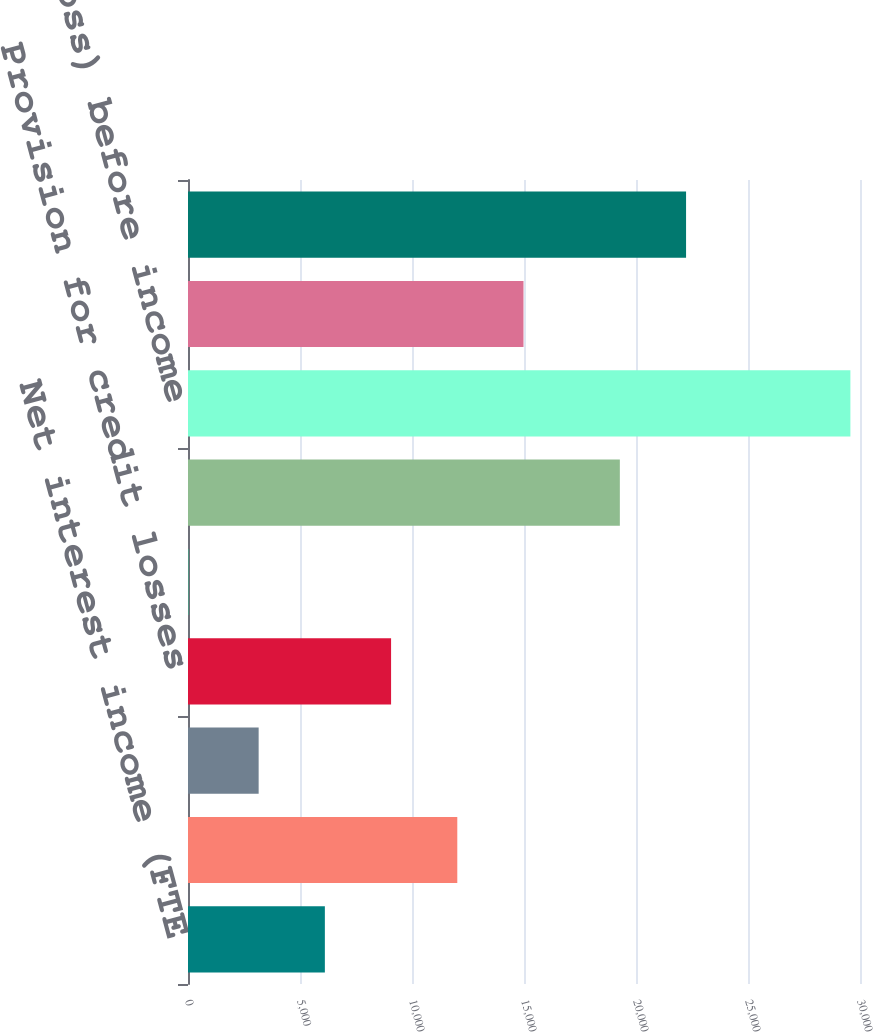Convert chart. <chart><loc_0><loc_0><loc_500><loc_500><bar_chart><fcel>Net interest income (FTE<fcel>Noninterest income<fcel>Total revenue net of interest<fcel>Provision for credit losses<fcel>Amortization of intangibles<fcel>Other noninterest expense<fcel>Income (loss) before income<fcel>Income tax expense (benefit)<fcel>Net income (loss)<nl><fcel>6110<fcel>12022<fcel>3154<fcel>9066<fcel>11<fcel>19279<fcel>29571<fcel>14978<fcel>22235<nl></chart> 